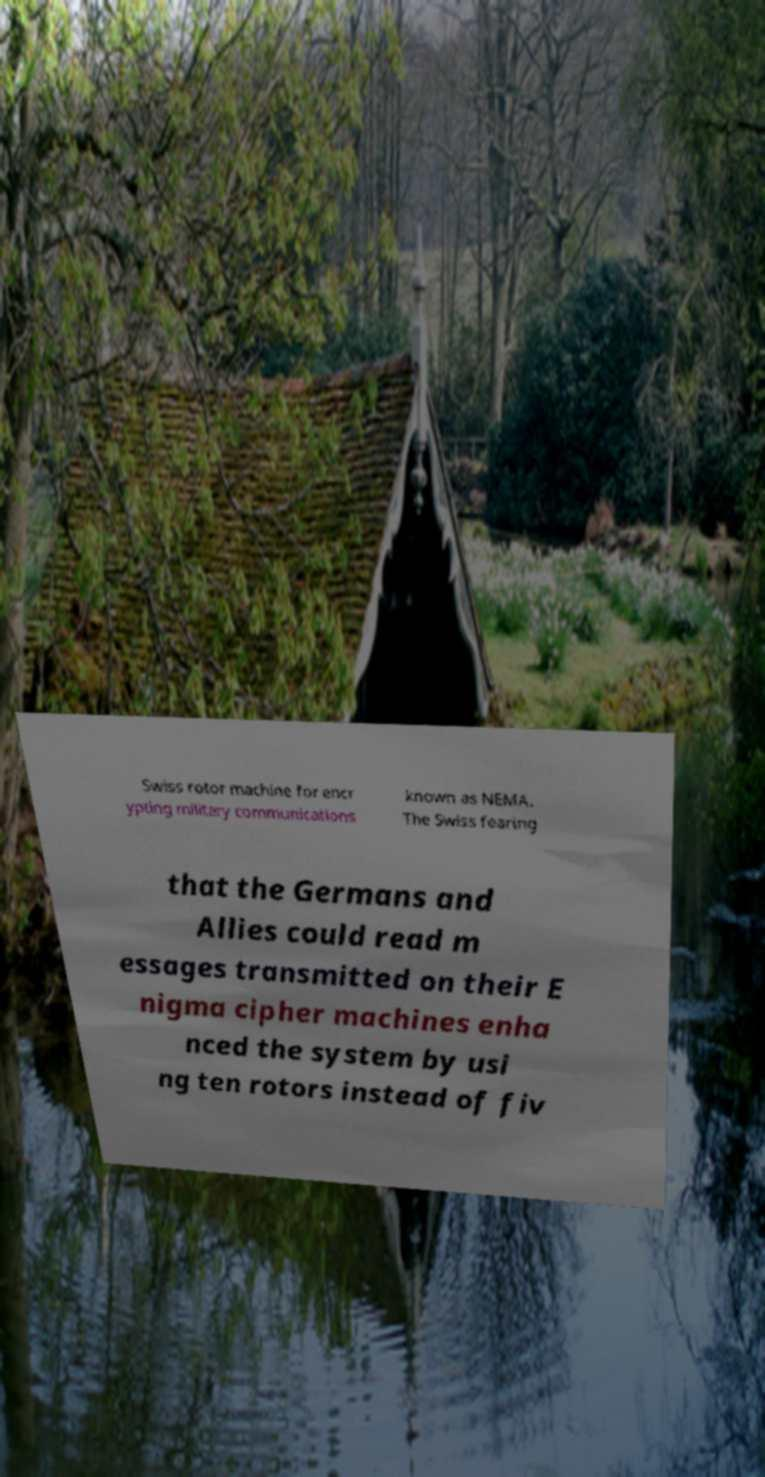Could you assist in decoding the text presented in this image and type it out clearly? Swiss rotor machine for encr ypting military communications known as NEMA. The Swiss fearing that the Germans and Allies could read m essages transmitted on their E nigma cipher machines enha nced the system by usi ng ten rotors instead of fiv 